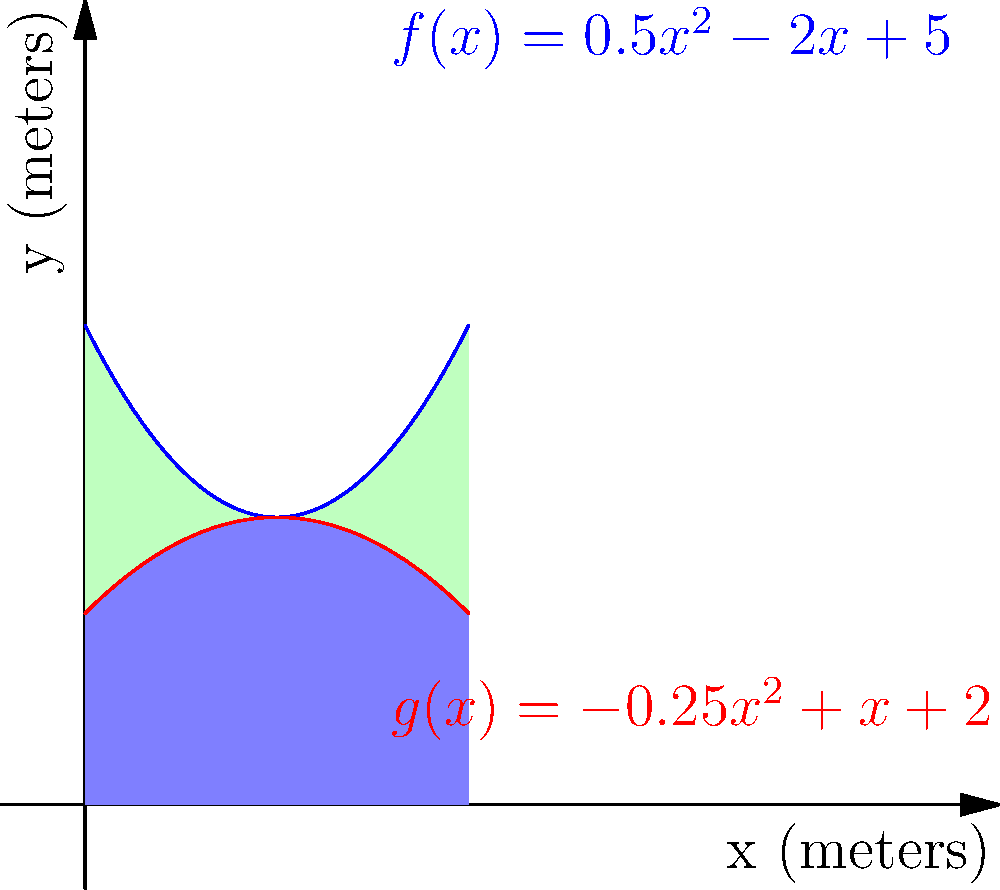You have an irregularly shaped piece of farmland bounded by two polynomial functions: $f(x)=0.5x^2-2x+5$ (blue curve) and $g(x)=-0.25x^2+x+2$ (red curve), where $x$ and $y$ are measured in meters. The farmland extends from $x=0$ to $x=4$. What is the total area of this farmland in square meters? To find the area of the irregularly shaped farmland, we need to:

1. Calculate the area under the upper curve ($f(x)$)
2. Calculate the area under the lower curve ($g(x)$)
3. Subtract the lower area from the upper area

Step 1: Area under $f(x)$
$$A_1 = \int_0^4 (0.5x^2-2x+5) dx$$
$$= [0.5 \cdot \frac{x^3}{3} - x^2 + 5x]_0^4$$
$$= (\frac{32}{3} - 16 + 20) - (0 - 0 + 0) = \frac{76}{3} \approx 25.33$$

Step 2: Area under $g(x)$
$$A_2 = \int_0^4 (-0.25x^2+x+2) dx$$
$$= [-0.25 \cdot \frac{x^3}{3} + \frac{x^2}{2} + 2x]_0^4$$
$$= (-\frac{16}{3} + 8 + 8) - (0 + 0 + 0) = \frac{32}{3} \approx 10.67$$

Step 3: Total area
$$A_{total} = A_1 - A_2 = \frac{76}{3} - \frac{32}{3} = \frac{44}{3} \approx 14.67$$

Therefore, the total area of the farmland is $\frac{44}{3}$ square meters.
Answer: $\frac{44}{3}$ square meters 